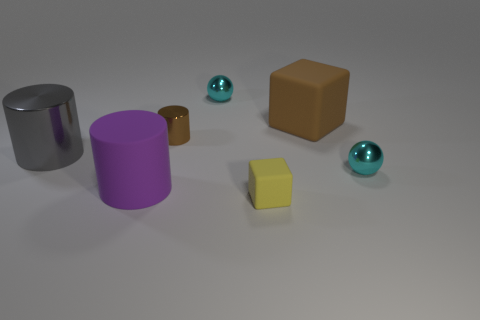Subtract all metallic cylinders. How many cylinders are left? 1 Add 2 big brown objects. How many objects exist? 9 Subtract 2 balls. How many balls are left? 0 Subtract all spheres. How many objects are left? 5 Subtract all large matte cylinders. Subtract all cyan things. How many objects are left? 4 Add 7 brown cylinders. How many brown cylinders are left? 8 Add 7 big gray metallic cylinders. How many big gray metallic cylinders exist? 8 Subtract all brown cylinders. How many cylinders are left? 2 Subtract 0 red spheres. How many objects are left? 7 Subtract all gray balls. Subtract all gray blocks. How many balls are left? 2 